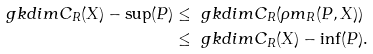Convert formula to latex. <formula><loc_0><loc_0><loc_500><loc_500>\ g k d i m { C } _ { R } ( X ) - \sup ( P ) & \leq \ g k d i m { C } _ { R } ( \rho m _ { R } ( P , X ) ) \\ & \leq \ g k d i m { C } _ { R } ( X ) - \inf ( P ) .</formula> 